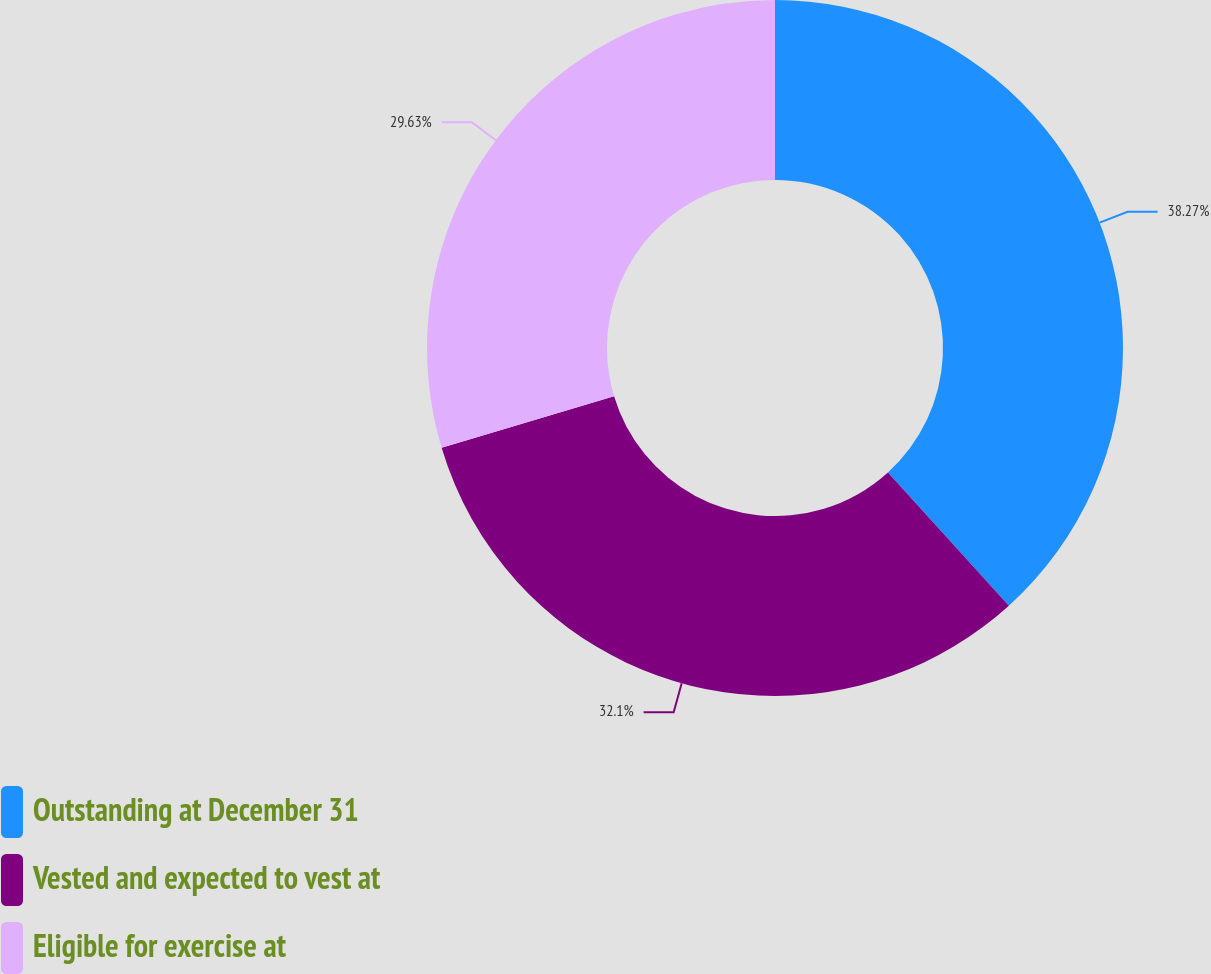Convert chart to OTSL. <chart><loc_0><loc_0><loc_500><loc_500><pie_chart><fcel>Outstanding at December 31<fcel>Vested and expected to vest at<fcel>Eligible for exercise at<nl><fcel>38.27%<fcel>32.1%<fcel>29.63%<nl></chart> 